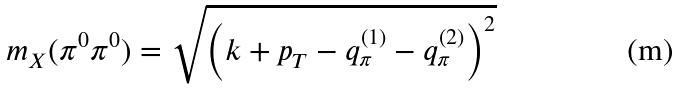Convert formula to latex. <formula><loc_0><loc_0><loc_500><loc_500>m _ { X } ( \pi ^ { 0 } \pi ^ { 0 } ) = \sqrt { \left ( k + p _ { T } - q _ { \pi } ^ { ( 1 ) } - q _ { \pi } ^ { ( 2 ) } \right ) ^ { 2 } }</formula> 